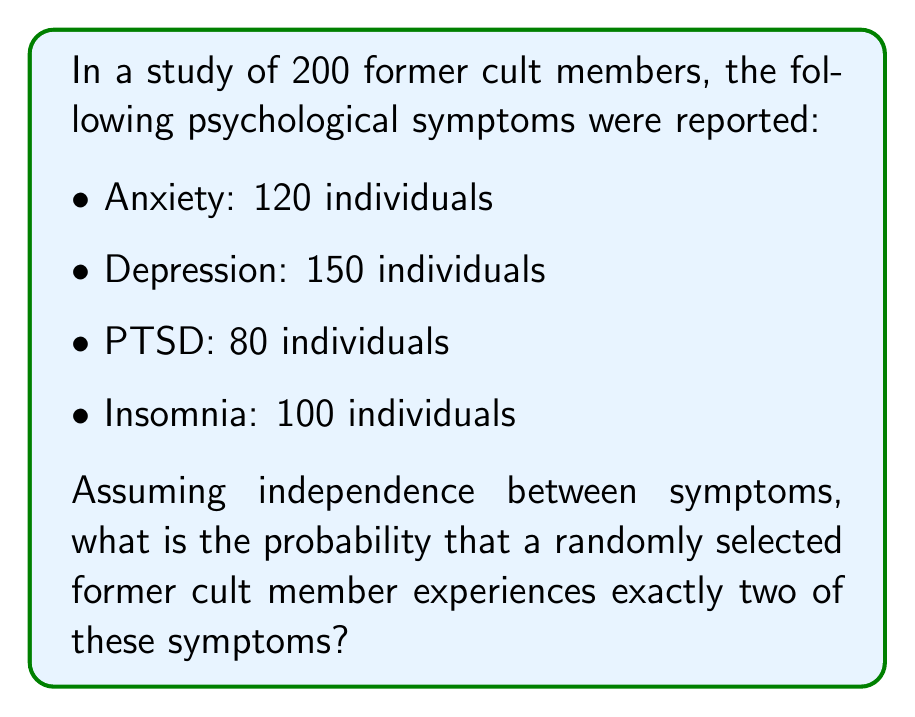Can you answer this question? To solve this problem, we'll use the concept of binomial probability distribution.

Step 1: Calculate the probability of experiencing each symptom.
$P(\text{Anxiety}) = 120/200 = 0.6$
$P(\text{Depression}) = 150/200 = 0.75$
$P(\text{PTSD}) = 80/200 = 0.4$
$P(\text{Insomnia}) = 100/200 = 0.5$

Step 2: Calculate the probability of not experiencing each symptom.
$P(\text{No Anxiety}) = 1 - 0.6 = 0.4$
$P(\text{No Depression}) = 1 - 0.75 = 0.25$
$P(\text{No PTSD}) = 1 - 0.4 = 0.6$
$P(\text{No Insomnia}) = 1 - 0.5 = 0.5$

Step 3: Use the binomial probability formula to calculate the probability of experiencing exactly 2 symptoms out of 4.

$$P(X=2) = \binom{4}{2} p^2 (1-p)^{4-2}$$

Where $p$ is the average probability of experiencing a symptom:
$p = (0.6 + 0.75 + 0.4 + 0.5) / 4 = 0.5625$

$$P(X=2) = \binom{4}{2} (0.5625)^2 (1-0.5625)^2$$
$$P(X=2) = 6 \times 0.5625^2 \times 0.4375^2$$
$$P(X=2) = 6 \times 0.316406 \times 0.191406$$
$$P(X=2) = 0.363$$

Therefore, the probability of a randomly selected former cult member experiencing exactly two of these symptoms is approximately 0.363 or 36.3%.
Answer: 0.363 